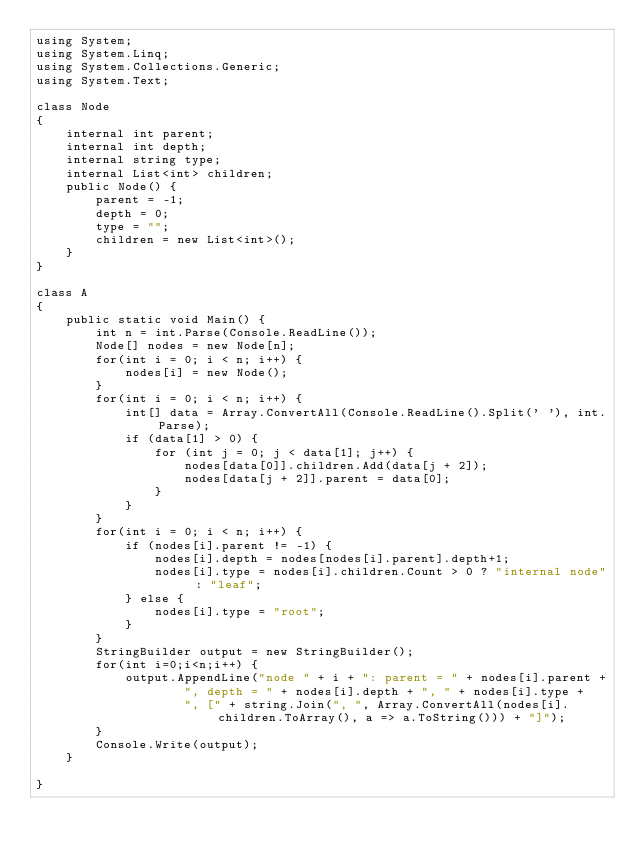<code> <loc_0><loc_0><loc_500><loc_500><_C#_>using System;
using System.Linq;
using System.Collections.Generic;
using System.Text;

class Node
{
    internal int parent;
    internal int depth;
    internal string type;
    internal List<int> children;
    public Node() {
        parent = -1;
        depth = 0;
        type = "";
        children = new List<int>();
    }
}

class A
{
    public static void Main() {
        int n = int.Parse(Console.ReadLine());
        Node[] nodes = new Node[n];
        for(int i = 0; i < n; i++) {
            nodes[i] = new Node();
        }
        for(int i = 0; i < n; i++) {
            int[] data = Array.ConvertAll(Console.ReadLine().Split(' '), int.Parse);
            if (data[1] > 0) {
                for (int j = 0; j < data[1]; j++) {
                    nodes[data[0]].children.Add(data[j + 2]);
                    nodes[data[j + 2]].parent = data[0];
                }
            }
        }
        for(int i = 0; i < n; i++) {            
            if (nodes[i].parent != -1) {
                nodes[i].depth = nodes[nodes[i].parent].depth+1;
                nodes[i].type = nodes[i].children.Count > 0 ? "internal node" : "leaf";
            } else {
                nodes[i].type = "root";
            }
        }
        StringBuilder output = new StringBuilder();
        for(int i=0;i<n;i++) {
            output.AppendLine("node " + i + ": parent = " + nodes[i].parent +
                    ", depth = " + nodes[i].depth + ", " + nodes[i].type +
                    ", [" + string.Join(", ", Array.ConvertAll(nodes[i].children.ToArray(), a => a.ToString())) + "]");
        }
        Console.Write(output);
    }
    
}
</code> 